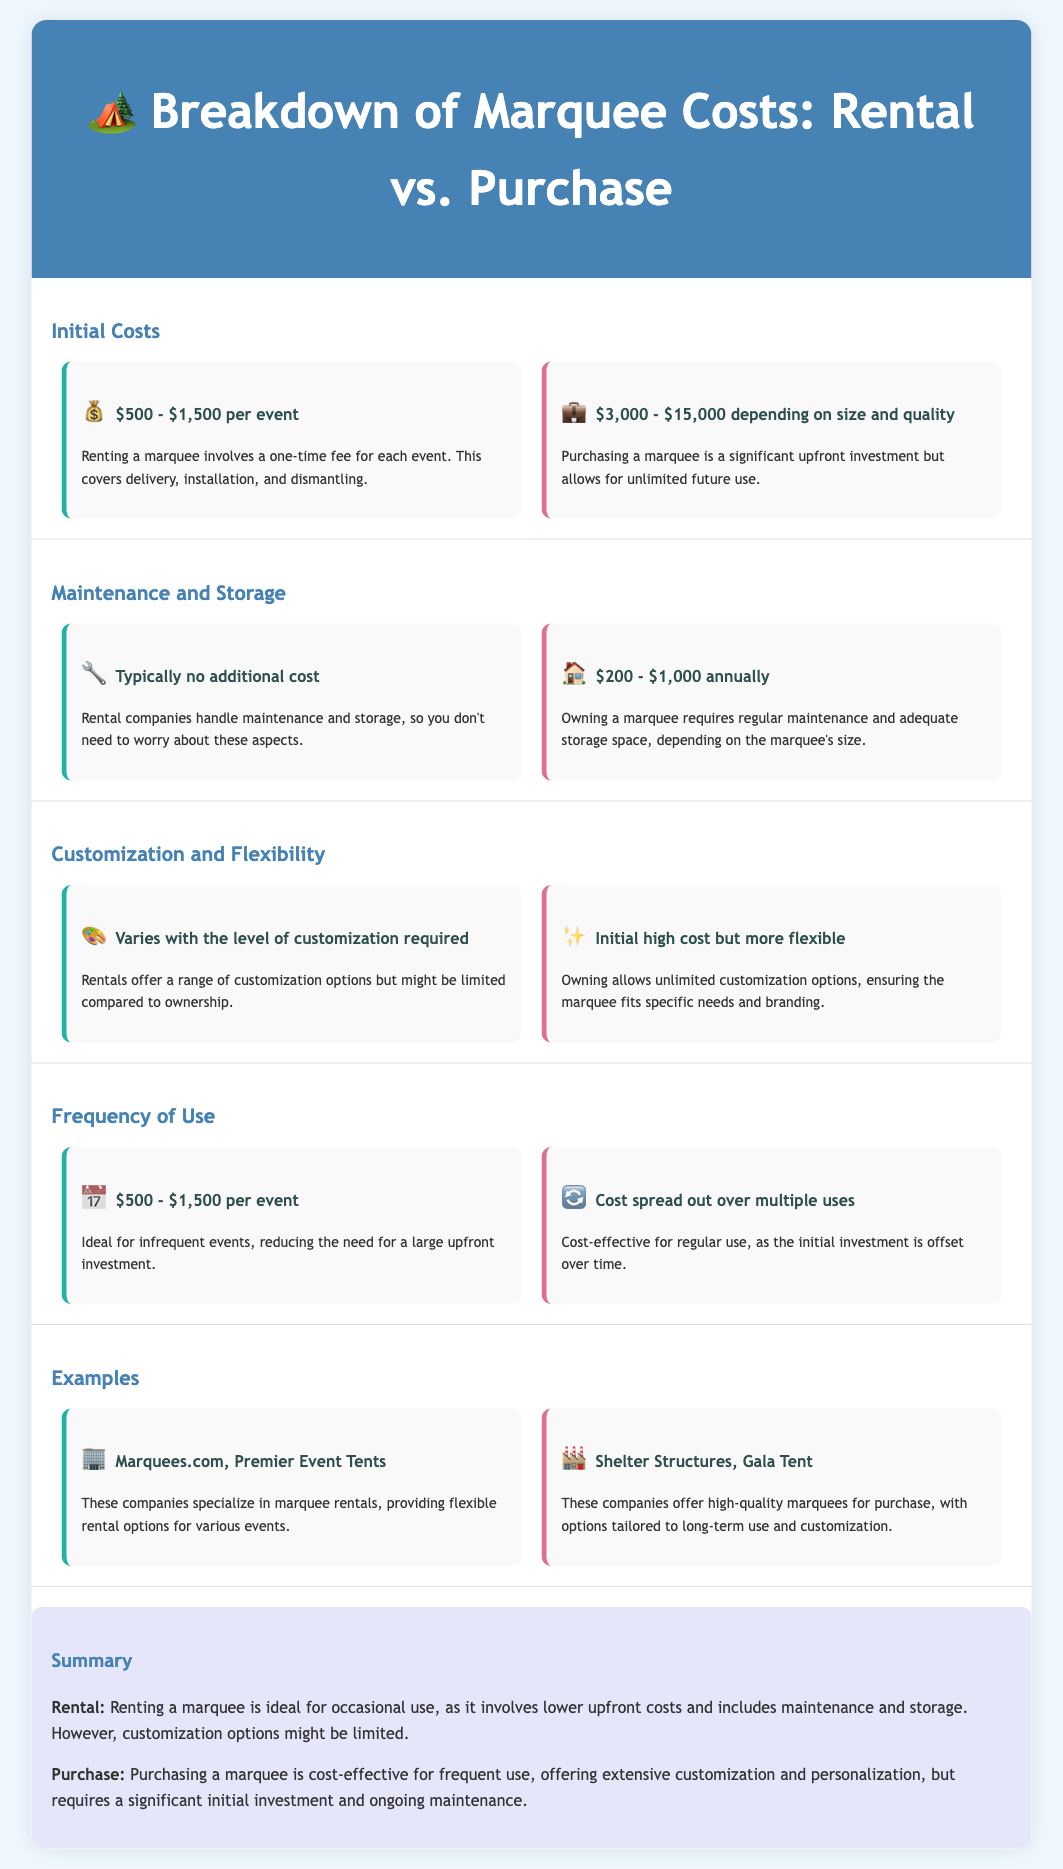what is the rental cost per event? The rental cost per event ranges from $500 to $1,500, as specified in the document.
Answer: $500 - $1,500 what is the purchase cost range? The purchase cost is detailed as $3,000 to $15,000 depending on size and quality.
Answer: $3,000 - $15,000 how much does maintaining a purchased marquee typically cost annually? The document states that maintenance for owning a marquee costs $200 to $1,000 annually.
Answer: $200 - $1,000 what is the typical storage cost for rentals? The document indicates that renting typically has no additional storage cost since rental companies handle it.
Answer: Typically no additional cost which option provides unlimited customization? The purchase option allows for unlimited customization, clearly mentioned in the document.
Answer: Purchase what type of events is renting ideal for? Renting is ideal for infrequent events, according to the document.
Answer: Infrequent events which companies are mentioned for renting marquees? The document lists Marquees.com and Premier Event Tents as companies specializing in rentals.
Answer: Marquees.com, Premier Event Tents what is one disadvantage of purchasing a marquee? A significant disadvantage is the high initial investment required for purchasing a marquee.
Answer: Significant initial investment how does purchasing provide cost-effectiveness? The document explains that purchasing is cost-effective for regular use, as the initial investment is offset over time.
Answer: Regular use 